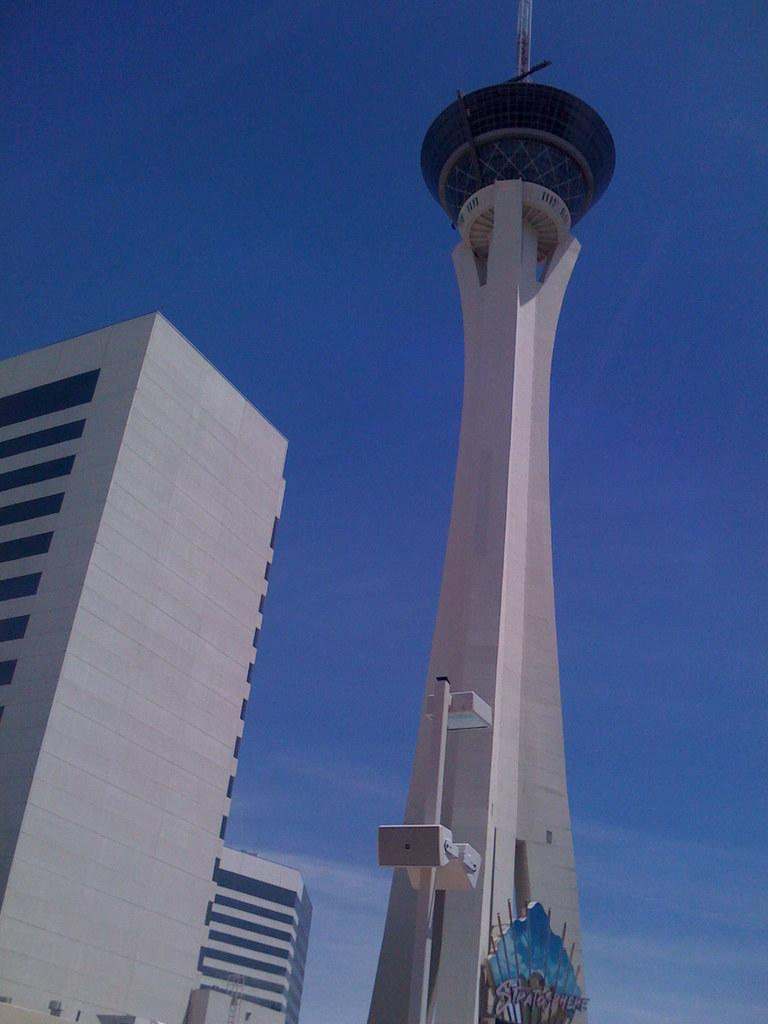What is the main structure in the image? There is a tower in the image. What feature can be seen on top of the tower? The tower has a helipad. What other structures are present in the image? There are buildings in the image. What is visible at the top of the image? The sky is clear and visible at the top of the image. What type of alarm can be heard going off in the image? There is no alarm present in the image, and therefore no such sound can be heard. Is there a sack of potatoes visible in the image? There is no sack of potatoes present in the image. 